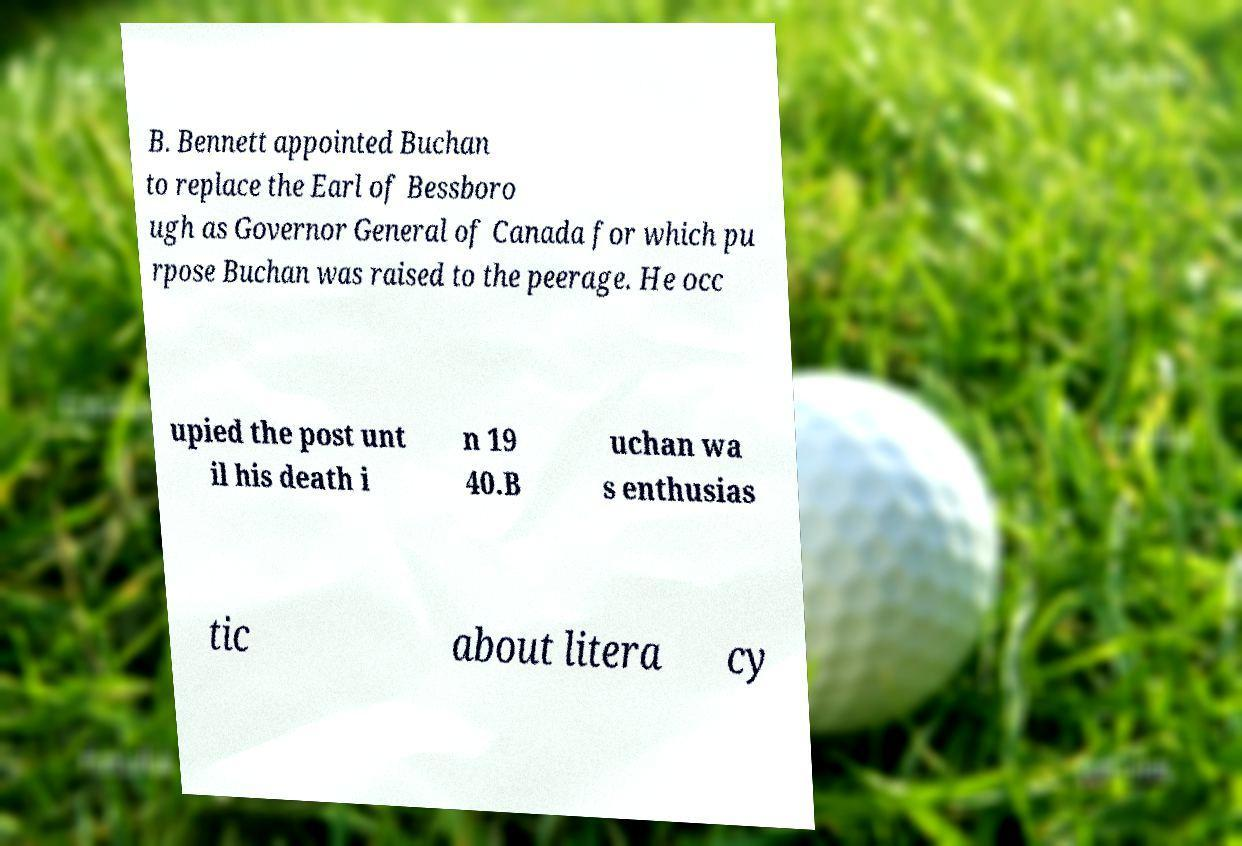For documentation purposes, I need the text within this image transcribed. Could you provide that? B. Bennett appointed Buchan to replace the Earl of Bessboro ugh as Governor General of Canada for which pu rpose Buchan was raised to the peerage. He occ upied the post unt il his death i n 19 40.B uchan wa s enthusias tic about litera cy 